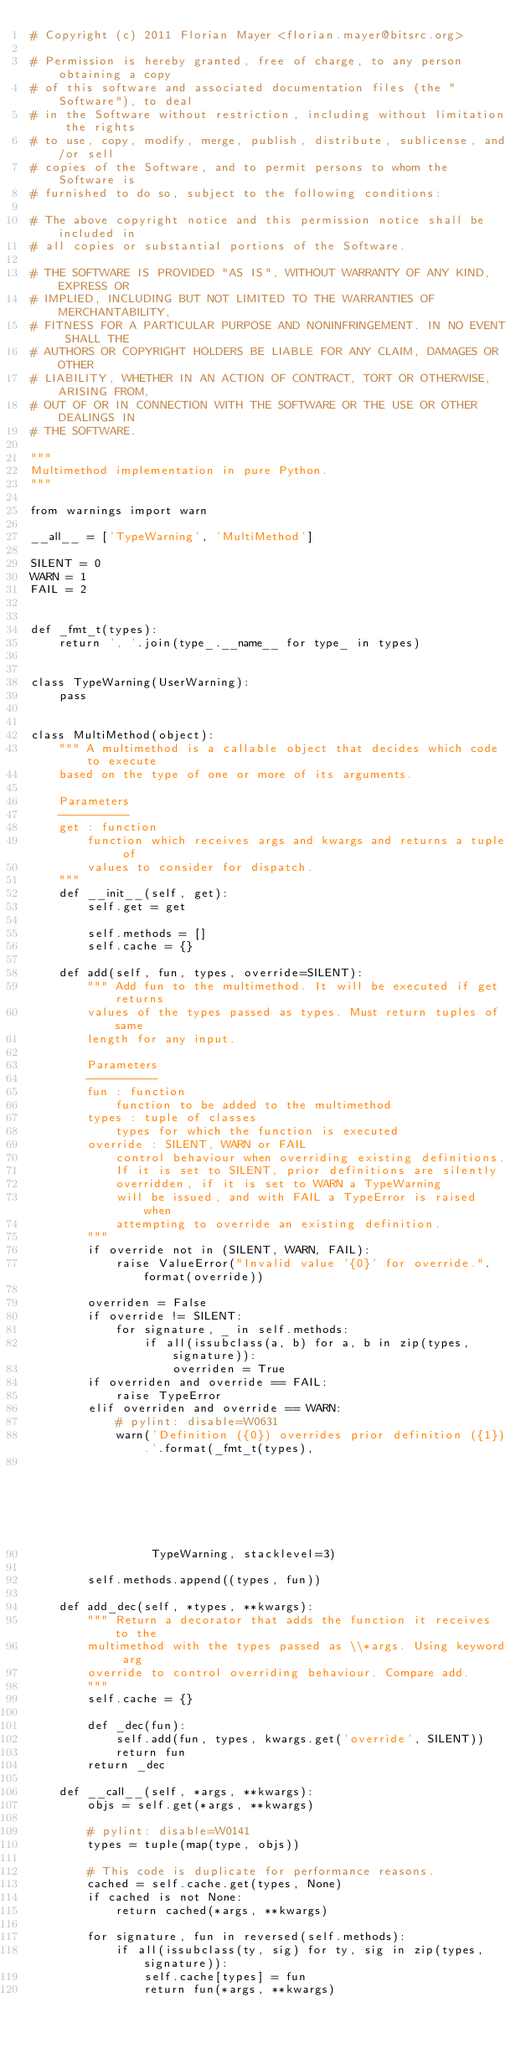Convert code to text. <code><loc_0><loc_0><loc_500><loc_500><_Python_># Copyright (c) 2011 Florian Mayer <florian.mayer@bitsrc.org>

# Permission is hereby granted, free of charge, to any person obtaining a copy
# of this software and associated documentation files (the "Software"), to deal
# in the Software without restriction, including without limitation the rights
# to use, copy, modify, merge, publish, distribute, sublicense, and/or sell
# copies of the Software, and to permit persons to whom the Software is
# furnished to do so, subject to the following conditions:

# The above copyright notice and this permission notice shall be included in
# all copies or substantial portions of the Software.

# THE SOFTWARE IS PROVIDED "AS IS", WITHOUT WARRANTY OF ANY KIND, EXPRESS OR
# IMPLIED, INCLUDING BUT NOT LIMITED TO THE WARRANTIES OF MERCHANTABILITY,
# FITNESS FOR A PARTICULAR PURPOSE AND NONINFRINGEMENT. IN NO EVENT SHALL THE
# AUTHORS OR COPYRIGHT HOLDERS BE LIABLE FOR ANY CLAIM, DAMAGES OR OTHER
# LIABILITY, WHETHER IN AN ACTION OF CONTRACT, TORT OR OTHERWISE, ARISING FROM,
# OUT OF OR IN CONNECTION WITH THE SOFTWARE OR THE USE OR OTHER DEALINGS IN
# THE SOFTWARE.

"""
Multimethod implementation in pure Python.
"""

from warnings import warn

__all__ = ['TypeWarning', 'MultiMethod']

SILENT = 0
WARN = 1
FAIL = 2


def _fmt_t(types):
    return ', '.join(type_.__name__ for type_ in types)


class TypeWarning(UserWarning):
    pass


class MultiMethod(object):
    """ A multimethod is a callable object that decides which code to execute
    based on the type of one or more of its arguments.

    Parameters
    ----------
    get : function
        function which receives args and kwargs and returns a tuple of
        values to consider for dispatch.
    """
    def __init__(self, get):
        self.get = get

        self.methods = []
        self.cache = {}

    def add(self, fun, types, override=SILENT):
        """ Add fun to the multimethod. It will be executed if get returns
        values of the types passed as types. Must return tuples of same
        length for any input.

        Parameters
        ----------
        fun : function
            function to be added to the multimethod
        types : tuple of classes
            types for which the function is executed
        override : SILENT, WARN or FAIL
            control behaviour when overriding existing definitions.
            If it is set to SILENT, prior definitions are silently
            overridden, if it is set to WARN a TypeWarning
            will be issued, and with FAIL a TypeError is raised when
            attempting to override an existing definition.
        """
        if override not in (SILENT, WARN, FAIL):
            raise ValueError("Invalid value '{0}' for override.".format(override))

        overriden = False
        if override != SILENT:
            for signature, _ in self.methods:
                if all(issubclass(a, b) for a, b in zip(types, signature)):
                    overriden = True
        if overriden and override == FAIL:
            raise TypeError
        elif overriden and override == WARN:
            # pylint: disable=W0631
            warn('Definition ({0}) overrides prior definition ({1}).'.format(_fmt_t(types),
                                                                             _fmt_t(signature)),
                 TypeWarning, stacklevel=3)

        self.methods.append((types, fun))

    def add_dec(self, *types, **kwargs):
        """ Return a decorator that adds the function it receives to the
        multimethod with the types passed as \\*args. Using keyword arg
        override to control overriding behaviour. Compare add.
        """
        self.cache = {}

        def _dec(fun):
            self.add(fun, types, kwargs.get('override', SILENT))
            return fun
        return _dec

    def __call__(self, *args, **kwargs):
        objs = self.get(*args, **kwargs)

        # pylint: disable=W0141
        types = tuple(map(type, objs))

        # This code is duplicate for performance reasons.
        cached = self.cache.get(types, None)
        if cached is not None:
            return cached(*args, **kwargs)

        for signature, fun in reversed(self.methods):
            if all(issubclass(ty, sig) for ty, sig in zip(types, signature)):
                self.cache[types] = fun
                return fun(*args, **kwargs)</code> 